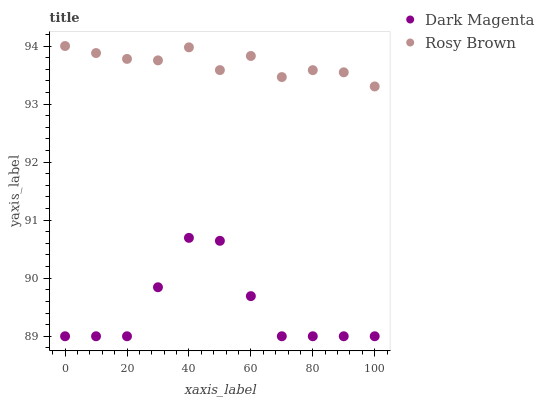Does Dark Magenta have the minimum area under the curve?
Answer yes or no. Yes. Does Rosy Brown have the maximum area under the curve?
Answer yes or no. Yes. Does Dark Magenta have the maximum area under the curve?
Answer yes or no. No. Is Rosy Brown the smoothest?
Answer yes or no. Yes. Is Dark Magenta the roughest?
Answer yes or no. Yes. Is Dark Magenta the smoothest?
Answer yes or no. No. Does Dark Magenta have the lowest value?
Answer yes or no. Yes. Does Rosy Brown have the highest value?
Answer yes or no. Yes. Does Dark Magenta have the highest value?
Answer yes or no. No. Is Dark Magenta less than Rosy Brown?
Answer yes or no. Yes. Is Rosy Brown greater than Dark Magenta?
Answer yes or no. Yes. Does Dark Magenta intersect Rosy Brown?
Answer yes or no. No. 